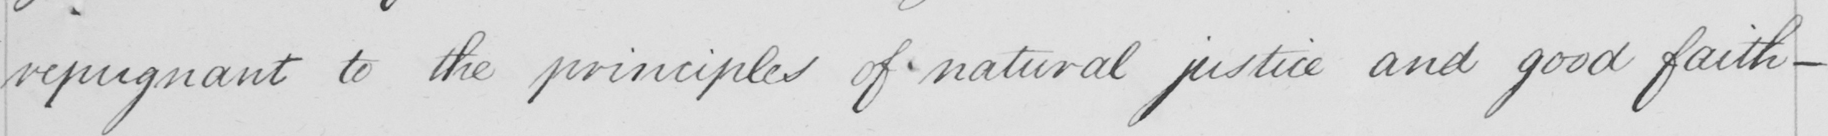Please provide the text content of this handwritten line. repugnant to the principles of natural justice and good faith  _ 